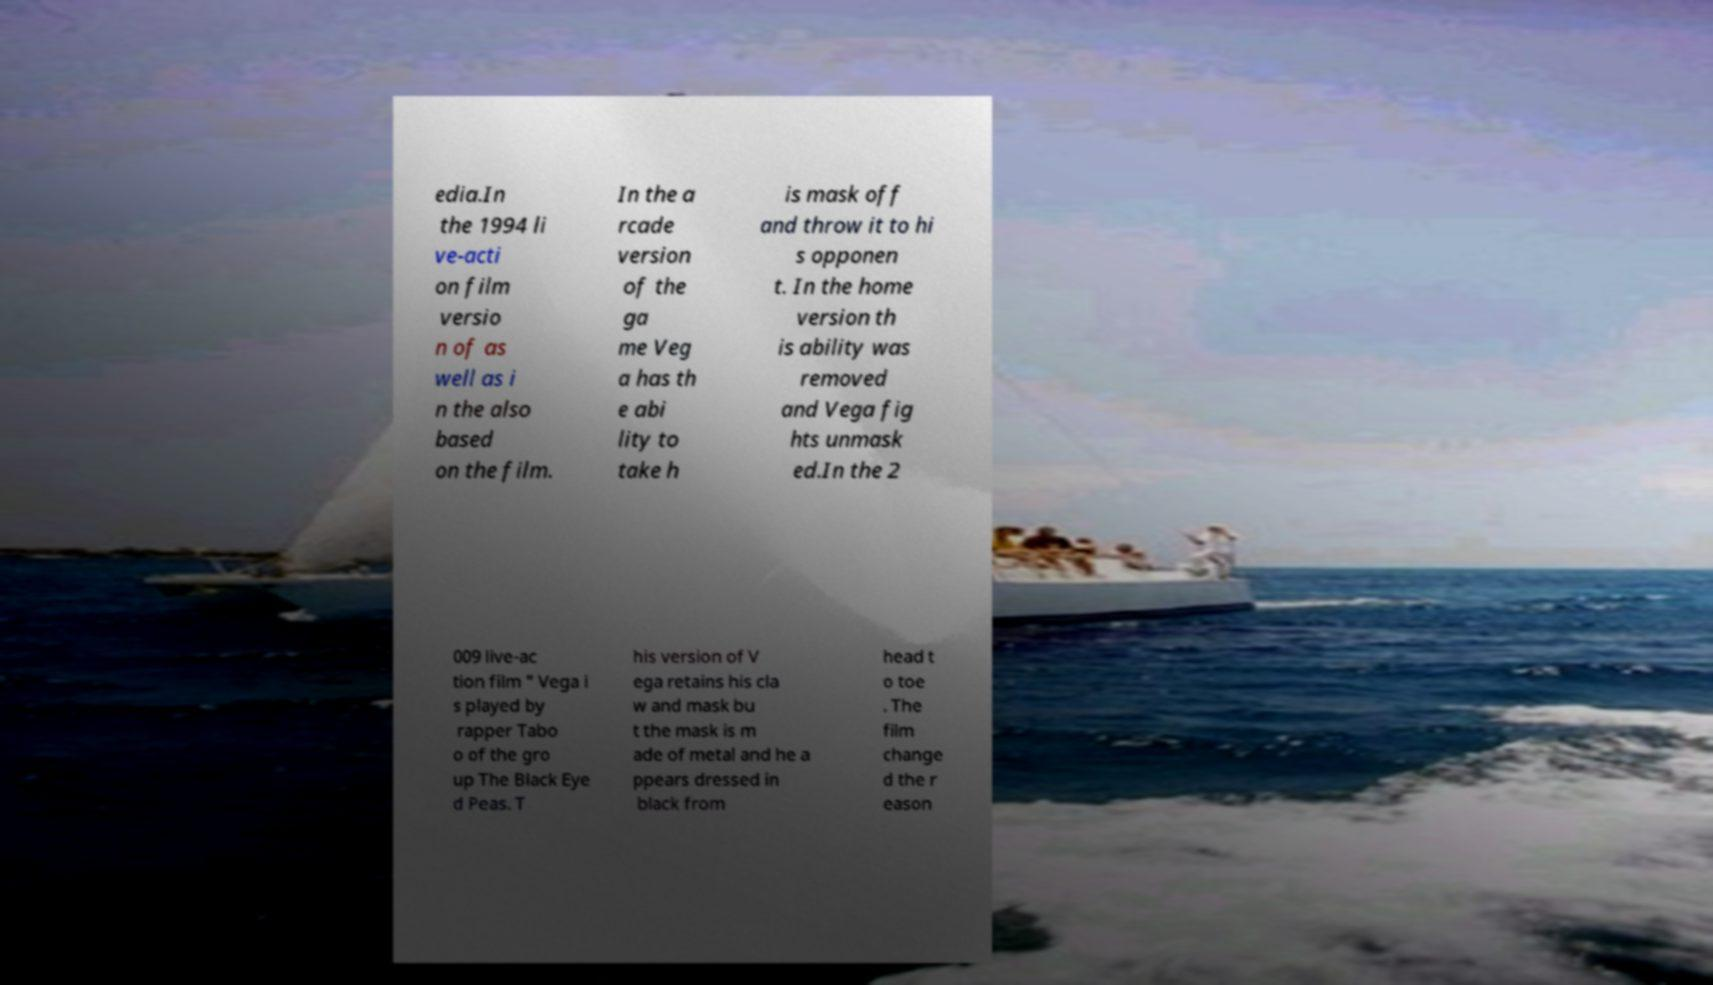Please identify and transcribe the text found in this image. edia.In the 1994 li ve-acti on film versio n of as well as i n the also based on the film. In the a rcade version of the ga me Veg a has th e abi lity to take h is mask off and throw it to hi s opponen t. In the home version th is ability was removed and Vega fig hts unmask ed.In the 2 009 live-ac tion film " Vega i s played by rapper Tabo o of the gro up The Black Eye d Peas. T his version of V ega retains his cla w and mask bu t the mask is m ade of metal and he a ppears dressed in black from head t o toe . The film change d the r eason 